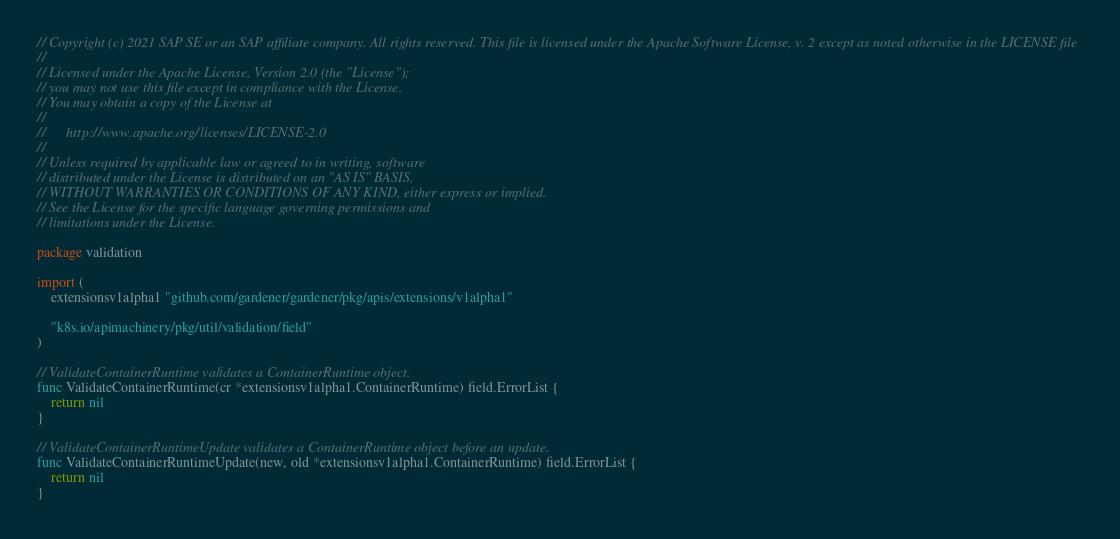<code> <loc_0><loc_0><loc_500><loc_500><_Go_>// Copyright (c) 2021 SAP SE or an SAP affiliate company. All rights reserved. This file is licensed under the Apache Software License, v. 2 except as noted otherwise in the LICENSE file
//
// Licensed under the Apache License, Version 2.0 (the "License");
// you may not use this file except in compliance with the License.
// You may obtain a copy of the License at
//
//      http://www.apache.org/licenses/LICENSE-2.0
//
// Unless required by applicable law or agreed to in writing, software
// distributed under the License is distributed on an "AS IS" BASIS,
// WITHOUT WARRANTIES OR CONDITIONS OF ANY KIND, either express or implied.
// See the License for the specific language governing permissions and
// limitations under the License.

package validation

import (
	extensionsv1alpha1 "github.com/gardener/gardener/pkg/apis/extensions/v1alpha1"

	"k8s.io/apimachinery/pkg/util/validation/field"
)

// ValidateContainerRuntime validates a ContainerRuntime object.
func ValidateContainerRuntime(cr *extensionsv1alpha1.ContainerRuntime) field.ErrorList {
	return nil
}

// ValidateContainerRuntimeUpdate validates a ContainerRuntime object before an update.
func ValidateContainerRuntimeUpdate(new, old *extensionsv1alpha1.ContainerRuntime) field.ErrorList {
	return nil
}
</code> 